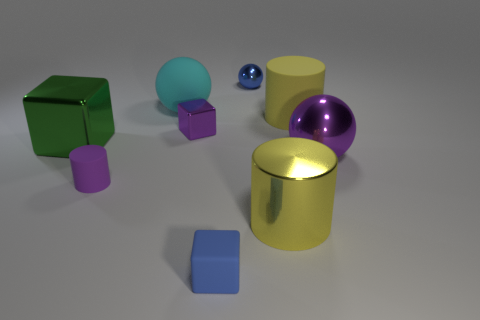How does the lighting in this image affect the appearance of the objects? The lighting in the image creates reflections and highlights that give depth and dimension to the objects. It also enhances the materials' perceived textures; for example, the golden cylinder appears shiny and reflective, suggesting it might be metallic, while the matte finish of the green cube suggests a more diffuse surface like plastic or painted wood.  Can you describe the shadow formations in the scene? Certainly, the shadows in the scene indicate a light source situated to the upper left, as they all extend diagonally to the lower right. The sharpness of shadows from the spherical objects suggests the light source is relatively small or distant. The varied lengths and angles of the shadows offer clues about the spatial arrangement of the objects and their relative sizes. 